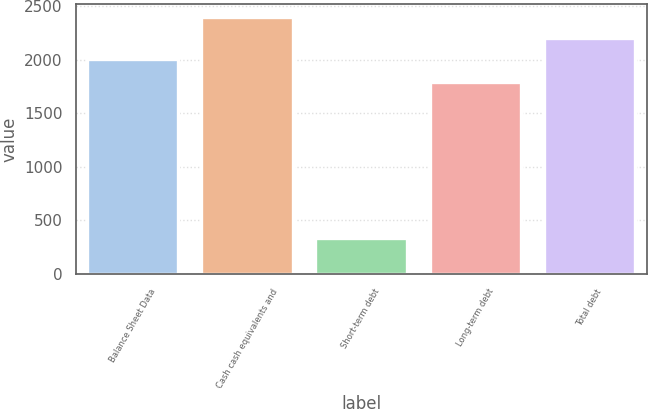<chart> <loc_0><loc_0><loc_500><loc_500><bar_chart><fcel>Balance Sheet Data<fcel>Cash cash equivalents and<fcel>Short-term debt<fcel>Long-term debt<fcel>Total debt<nl><fcel>2008<fcel>2396.42<fcel>332.8<fcel>1786.9<fcel>2202.21<nl></chart> 